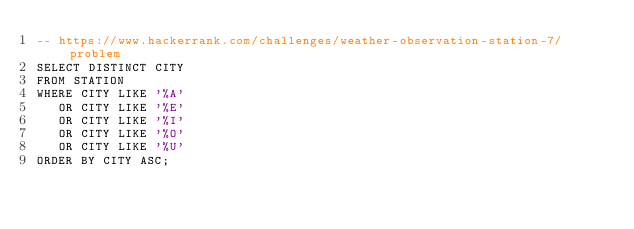Convert code to text. <code><loc_0><loc_0><loc_500><loc_500><_SQL_>-- https://www.hackerrank.com/challenges/weather-observation-station-7/problem
SELECT DISTINCT CITY
FROM STATION
WHERE CITY LIKE '%A'
   OR CITY LIKE '%E'
   OR CITY LIKE '%I'
   OR CITY LIKE '%O'
   OR CITY LIKE '%U'
ORDER BY CITY ASC;
</code> 